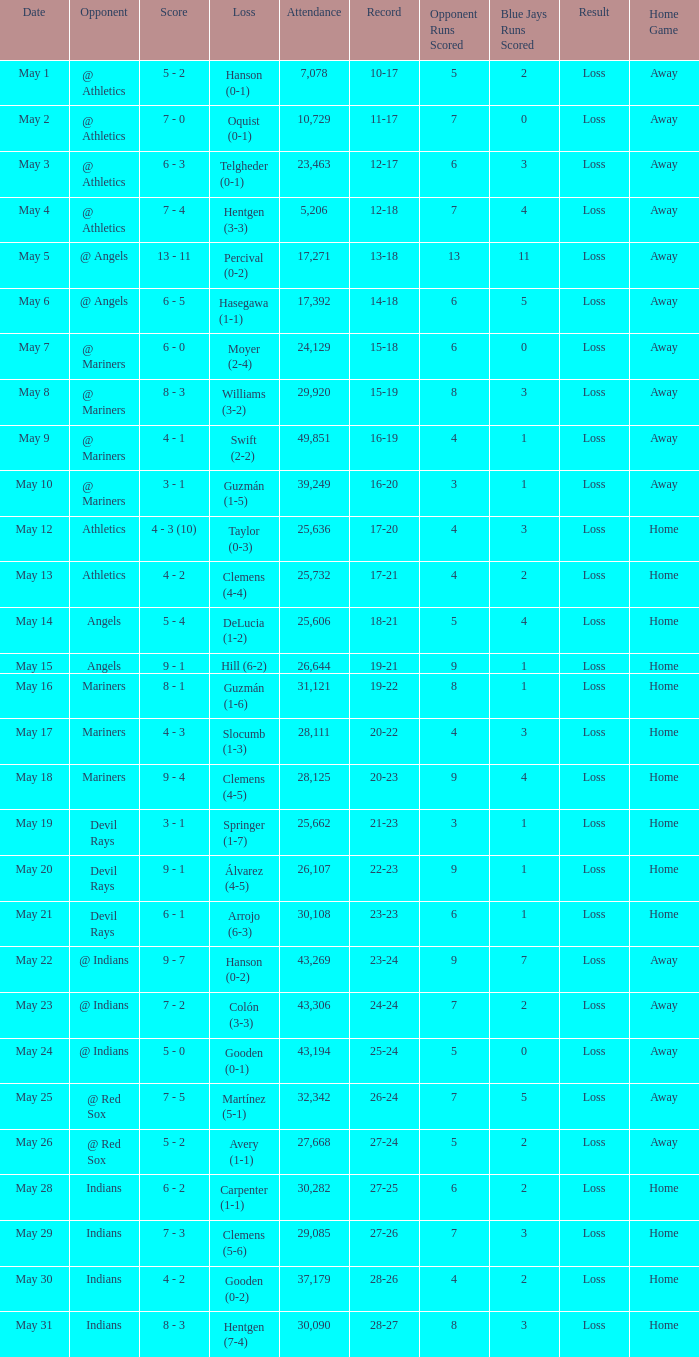For record 25-24, what is the sum of attendance? 1.0. 